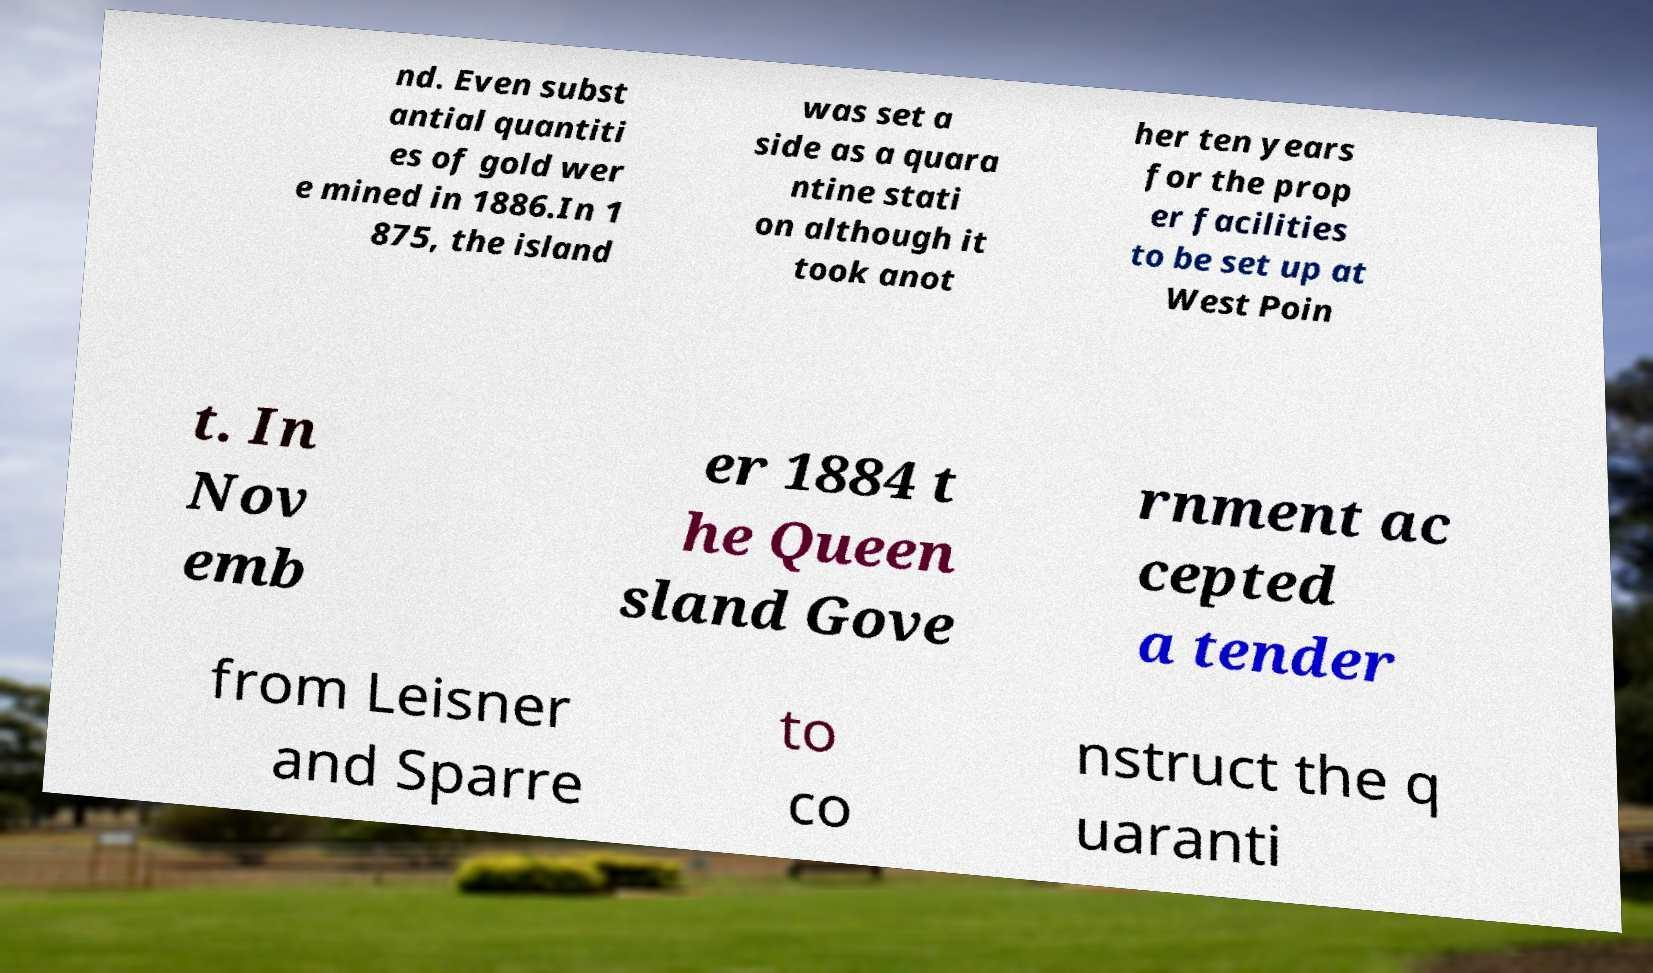There's text embedded in this image that I need extracted. Can you transcribe it verbatim? nd. Even subst antial quantiti es of gold wer e mined in 1886.In 1 875, the island was set a side as a quara ntine stati on although it took anot her ten years for the prop er facilities to be set up at West Poin t. In Nov emb er 1884 t he Queen sland Gove rnment ac cepted a tender from Leisner and Sparre to co nstruct the q uaranti 